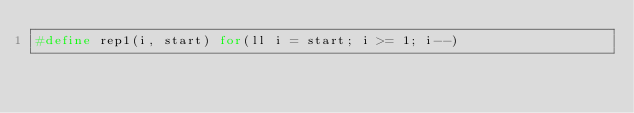<code> <loc_0><loc_0><loc_500><loc_500><_C++_>#define rep1(i, start) for(ll i = start; i >= 1; i--)</code> 